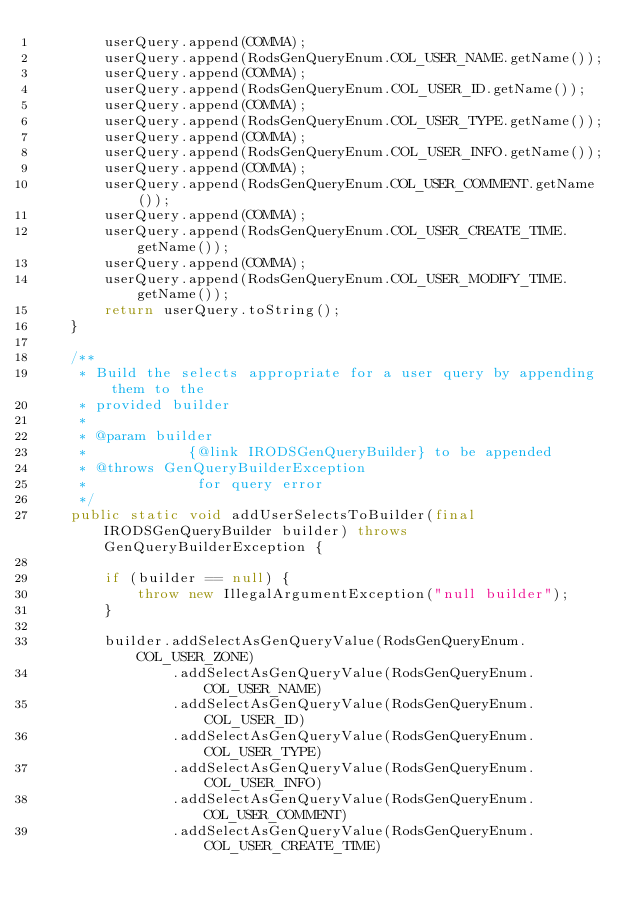<code> <loc_0><loc_0><loc_500><loc_500><_Java_>		userQuery.append(COMMA);
		userQuery.append(RodsGenQueryEnum.COL_USER_NAME.getName());
		userQuery.append(COMMA);
		userQuery.append(RodsGenQueryEnum.COL_USER_ID.getName());
		userQuery.append(COMMA);
		userQuery.append(RodsGenQueryEnum.COL_USER_TYPE.getName());
		userQuery.append(COMMA);
		userQuery.append(RodsGenQueryEnum.COL_USER_INFO.getName());
		userQuery.append(COMMA);
		userQuery.append(RodsGenQueryEnum.COL_USER_COMMENT.getName());
		userQuery.append(COMMA);
		userQuery.append(RodsGenQueryEnum.COL_USER_CREATE_TIME.getName());
		userQuery.append(COMMA);
		userQuery.append(RodsGenQueryEnum.COL_USER_MODIFY_TIME.getName());
		return userQuery.toString();
	}

	/**
	 * Build the selects appropriate for a user query by appending them to the
	 * provided builder
	 *
	 * @param builder
	 *            {@link IRODSGenQueryBuilder} to be appended
	 * @throws GenQueryBuilderException
	 *             for query error
	 */
	public static void addUserSelectsToBuilder(final IRODSGenQueryBuilder builder) throws GenQueryBuilderException {

		if (builder == null) {
			throw new IllegalArgumentException("null builder");
		}

		builder.addSelectAsGenQueryValue(RodsGenQueryEnum.COL_USER_ZONE)
				.addSelectAsGenQueryValue(RodsGenQueryEnum.COL_USER_NAME)
				.addSelectAsGenQueryValue(RodsGenQueryEnum.COL_USER_ID)
				.addSelectAsGenQueryValue(RodsGenQueryEnum.COL_USER_TYPE)
				.addSelectAsGenQueryValue(RodsGenQueryEnum.COL_USER_INFO)
				.addSelectAsGenQueryValue(RodsGenQueryEnum.COL_USER_COMMENT)
				.addSelectAsGenQueryValue(RodsGenQueryEnum.COL_USER_CREATE_TIME)</code> 